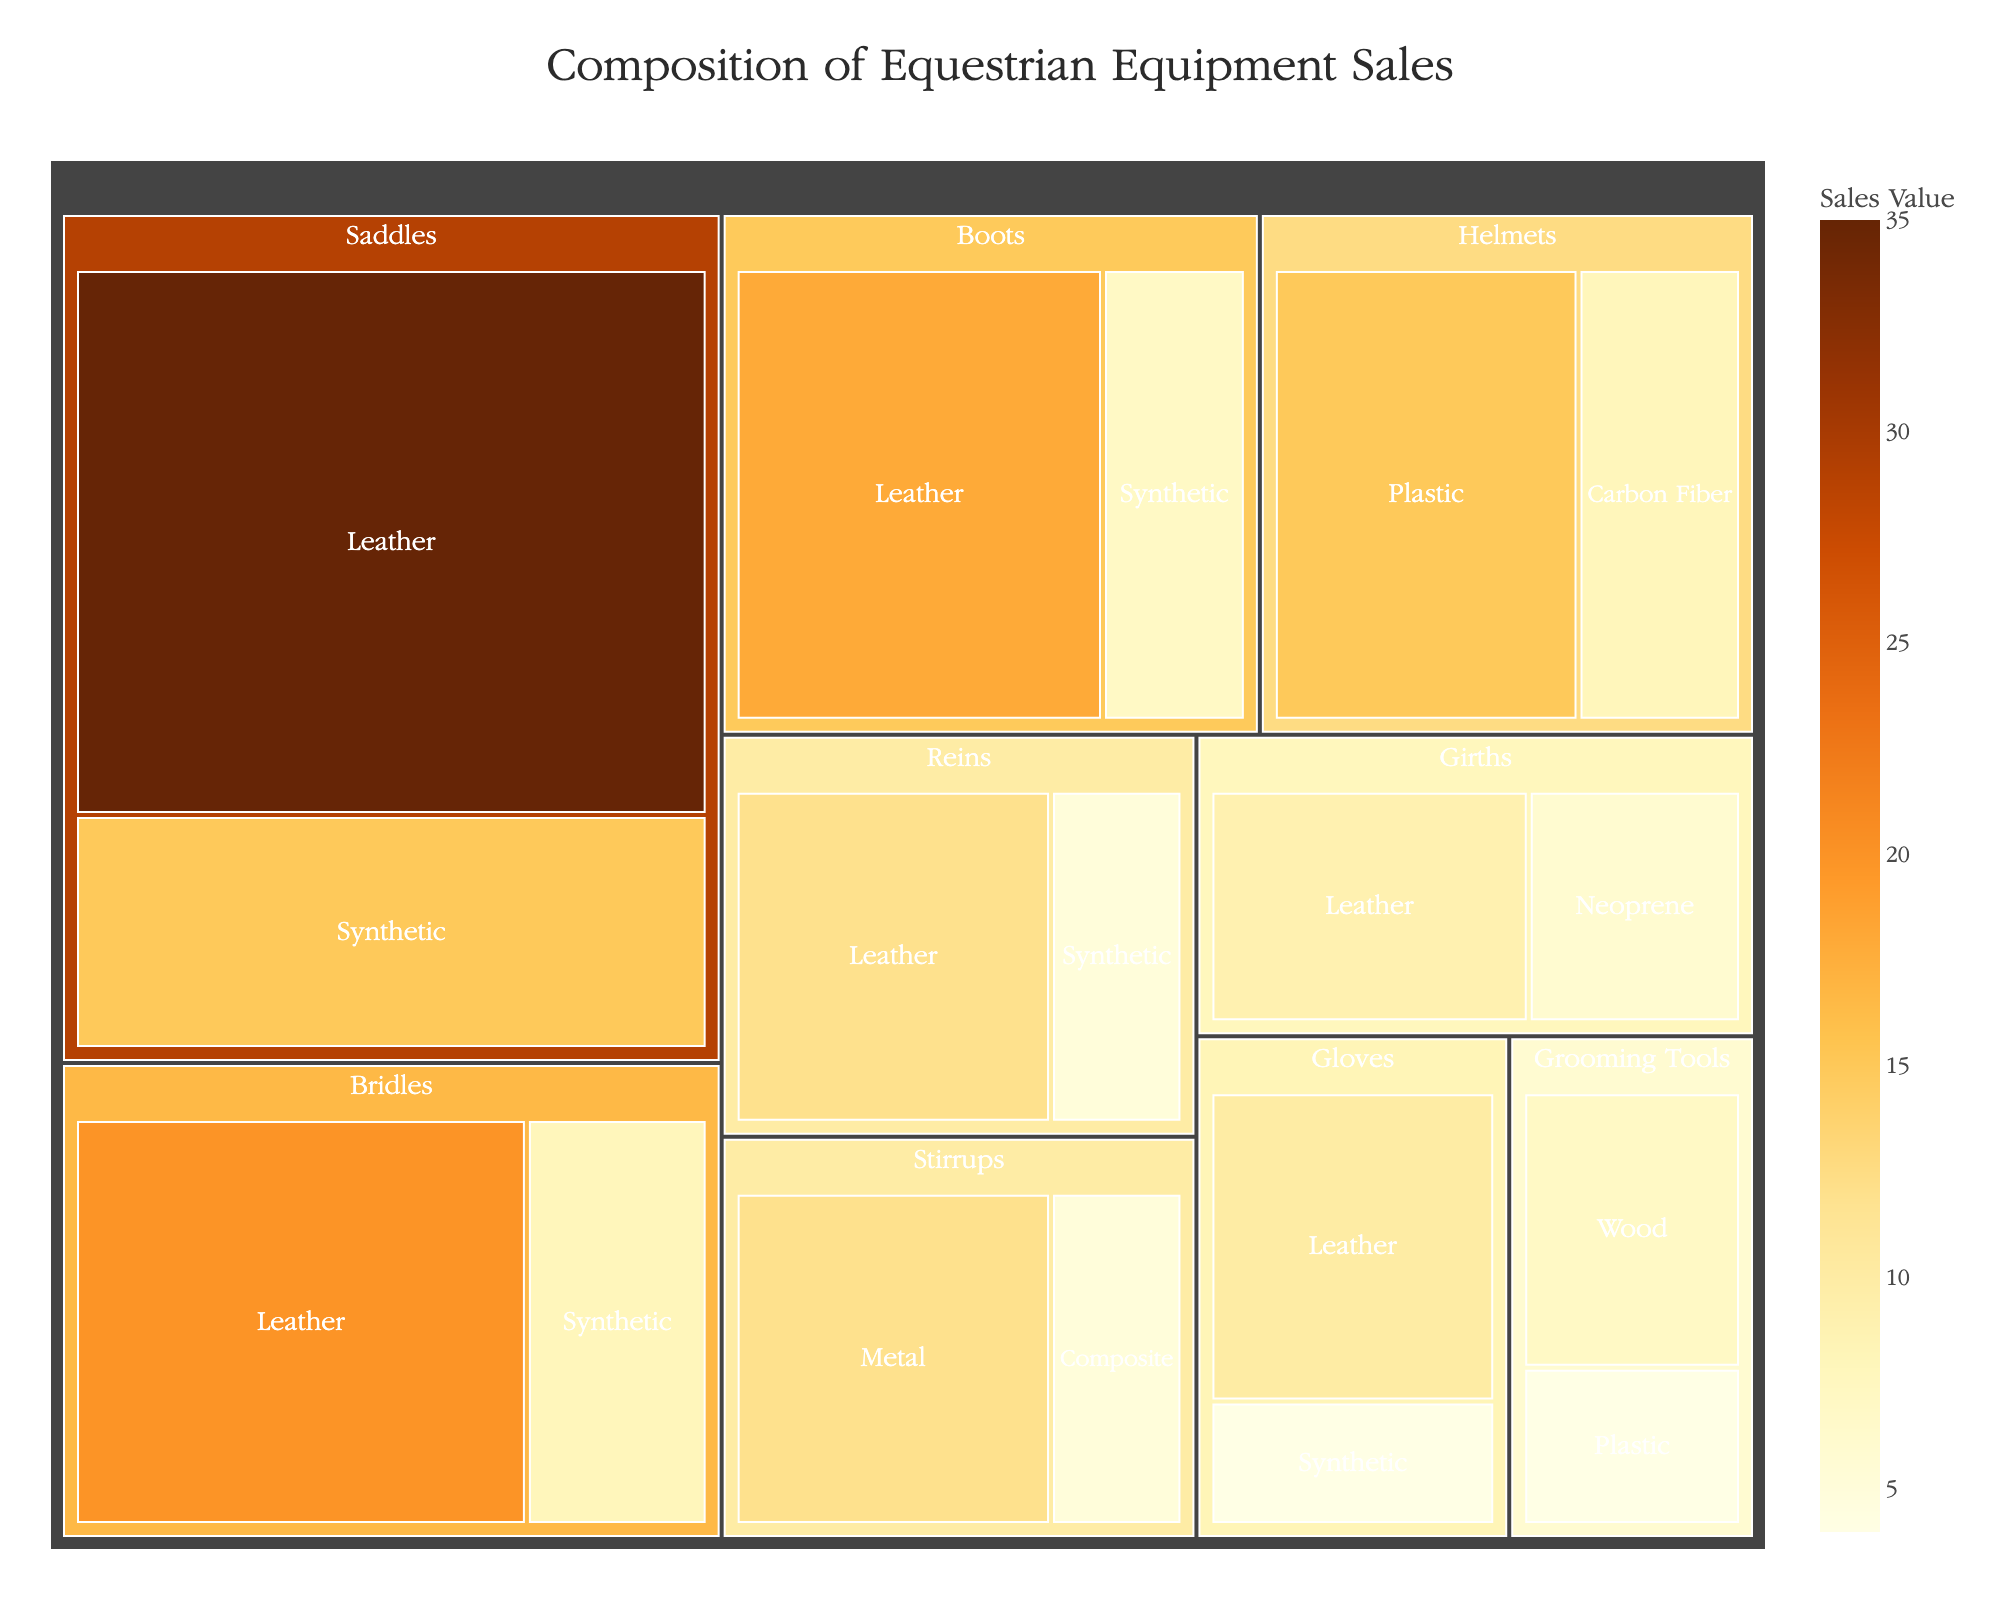what is the title of the figure? the title is located at the top center of the figure. it reads "Composition of Equestrian Equipment Sales"
Answer: Composition of Equestrian Equipment Sales Which subcategory has the highest sales value within Saddles? The treemap shows two subcategories under Saddles: Leather and Synthetic. Leather has a higher value of 35
Answer: Leather How do the sales of leather Bridles compare to synthetic Bridles? By comparing the size of the segments in the Bridles category, leather bridles have a value of 20, whereas synthetic bridles have a value of 8. Therefore, leather bridles have higher sales
Answer: Leather bridles have higher sales Which category has the smallest overall sales value? By examining the size of the segments, Grooming Tools appears to be the smallest category with values of 7 (wood) and 4 (plastic), totaling 11
Answer: Grooming Tools What is the sum of sales values for Helmets? Helmets has two subcategories with values: plastic (15) and carbon fiber (8). Adding these together gives 15 + 8 = 23
Answer: 23 In the Saddles category, what is the difference in sales between leather and synthetic materials? By subtracting the sales value of synthetic saddles (15) from leather saddles (35), the difference is 35 - 15 = 20
Answer: 20 What material has the highest sales value across all categories? By looking at the color intensity in the treemap, leather in saddles has the highest sales value of 35
Answer: Leather (in Saddles) How do the sales of leather Reins compare to leather Bridles? By comparing their sales values, leather Reins have a value of 12, whereas leather Bridles have a value of 20. Therefore, leather bridles have higher sales
Answer: Leather bridles have higher sales What is the average sales value of synthetic materials? Synthetic materials include: Saddles (15), Bridles (8), Reins (5), Boots (7), and Gloves (4). Their total is 15 + 8 + 5 + 7 + 4 = 39. There are 5 items, so the average is 39 / 5 = 7.8
Answer: 7.8 Which subcategory has the second highest sales value within Boots? By comparing the sales values within Boots: Leather (18) and Synthetic (7). The second highest is synthetic with a value of 7
Answer: Synthetic 